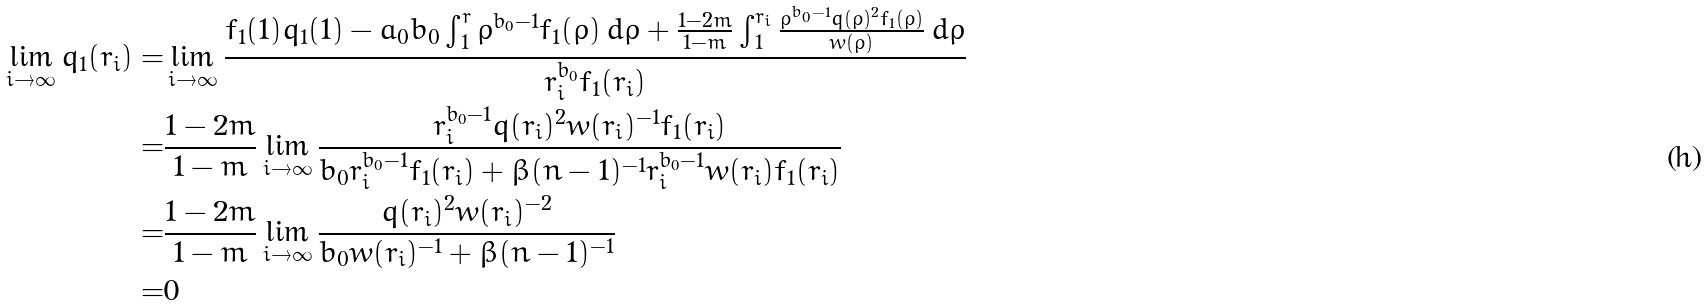Convert formula to latex. <formula><loc_0><loc_0><loc_500><loc_500>\lim _ { i \to \infty } q _ { 1 } ( r _ { i } ) = & \lim _ { i \to \infty } \frac { f _ { 1 } ( 1 ) q _ { 1 } ( 1 ) - a _ { 0 } b _ { 0 } \int _ { 1 } ^ { r } \rho ^ { b _ { 0 } - 1 } f _ { 1 } ( \rho ) \, d \rho + \frac { 1 - 2 m } { 1 - m } \int _ { 1 } ^ { r _ { i } } \frac { \rho ^ { b _ { 0 } - 1 } q ( \rho ) ^ { 2 } f _ { 1 } ( \rho ) } { w ( \rho ) } \, d \rho } { r _ { i } ^ { b _ { 0 } } f _ { 1 } ( r _ { i } ) } \\ = & \frac { 1 - 2 m } { 1 - m } \lim _ { i \to \infty } \frac { r _ { i } ^ { b _ { 0 } - 1 } q ( r _ { i } ) ^ { 2 } w ( r _ { i } ) ^ { - 1 } f _ { 1 } ( r _ { i } ) } { b _ { 0 } r _ { i } ^ { b _ { 0 } - 1 } f _ { 1 } ( r _ { i } ) + \beta ( n - 1 ) ^ { - 1 } r _ { i } ^ { b _ { 0 } - 1 } w ( r _ { i } ) f _ { 1 } ( r _ { i } ) } \\ = & \frac { 1 - 2 m } { 1 - m } \lim _ { i \to \infty } \frac { q ( r _ { i } ) ^ { 2 } w ( r _ { i } ) ^ { - 2 } } { b _ { 0 } w ( r _ { i } ) ^ { - 1 } + \beta ( n - 1 ) ^ { - 1 } } \\ = & 0</formula> 